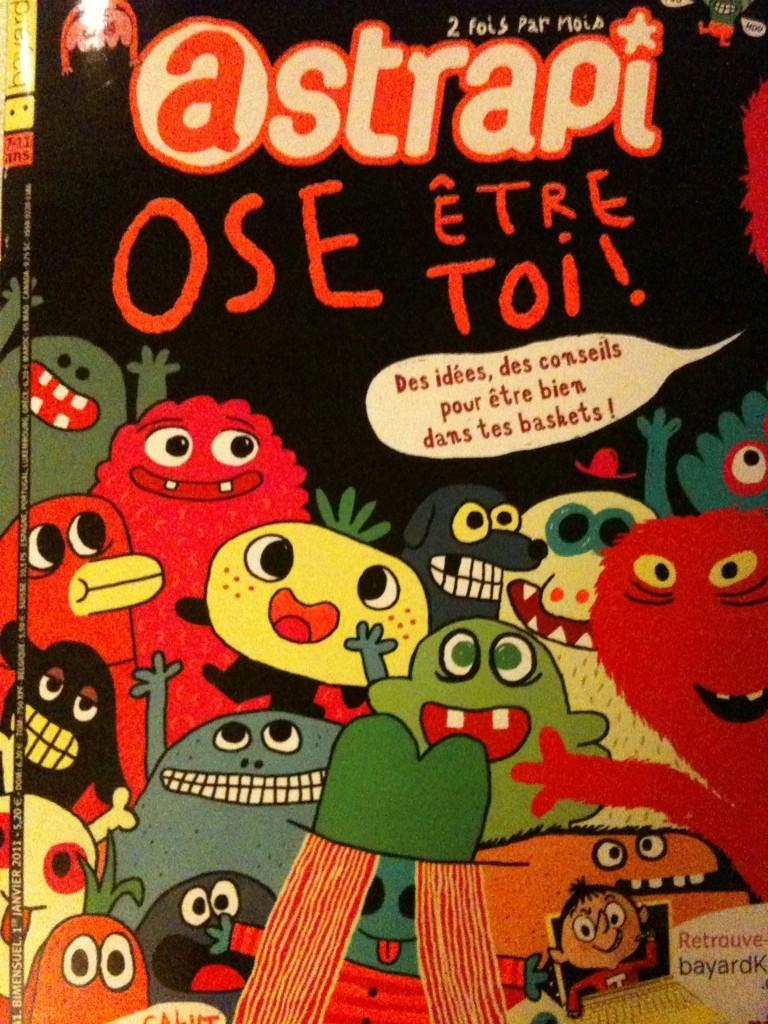What is present in the image that contains visuals and text? There is a poster in the image that contains pictures of animated creatures and text. Can you describe the content of the poster? The poster contains pictures of animated creatures. What else can be found on the poster besides the images? There is text on the poster. Is there a secretary holding a quill in the image? No, there is no secretary or quill present in the image. The image only contains a poster with pictures of animated creatures and text. 